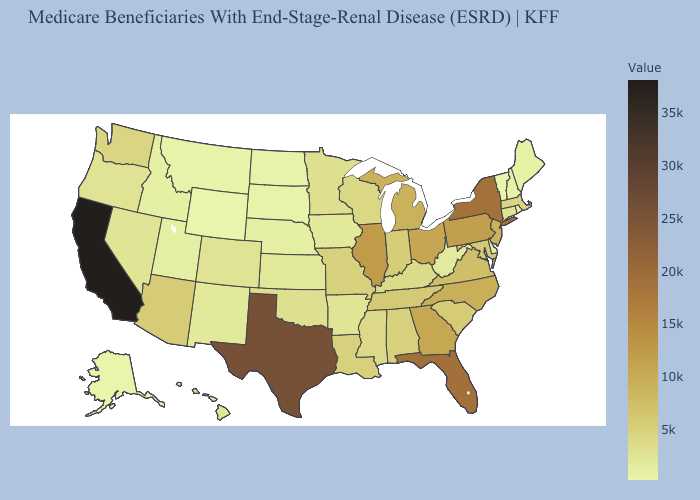Among the states that border Washington , does Oregon have the highest value?
Short answer required. Yes. Does Massachusetts have the lowest value in the USA?
Keep it brief. No. Which states have the highest value in the USA?
Quick response, please. California. Which states hav the highest value in the MidWest?
Short answer required. Illinois. Among the states that border Oklahoma , which have the lowest value?
Answer briefly. New Mexico. Among the states that border Maryland , does West Virginia have the highest value?
Answer briefly. No. Does North Carolina have the highest value in the USA?
Write a very short answer. No. Does Georgia have the lowest value in the USA?
Give a very brief answer. No. Does New Hampshire have the highest value in the Northeast?
Be succinct. No. 